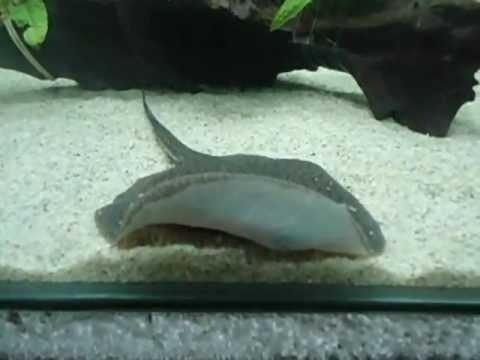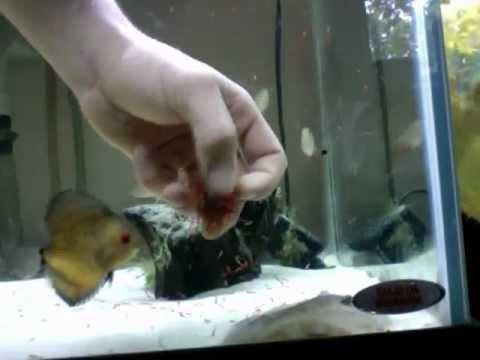The first image is the image on the left, the second image is the image on the right. Analyze the images presented: Is the assertion "A person is hand feeding a marine animal." valid? Answer yes or no. Yes. The first image is the image on the left, the second image is the image on the right. Evaluate the accuracy of this statement regarding the images: "In one of the images, a human hand is interacting with a fish.". Is it true? Answer yes or no. Yes. 